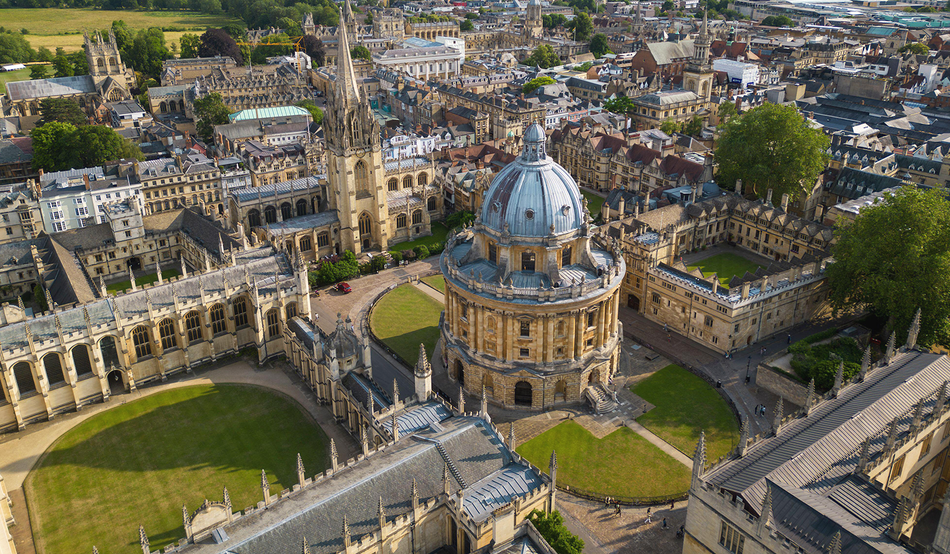This seems like an old university. How has it influenced academia? Oxford University's influence on academia is immense. As the oldest university in the English-speaking world, dating back to the 12th century, it has been a center of scholarship that helped shape educational standards worldwide. It has a long history of nurturing scientific enquiry, literature, and political thought. Many notable alumni, including world leaders, Nobel laureates, and scholars, have walked its halls, contributing significantly to the advancement of knowledge across disciplines. 